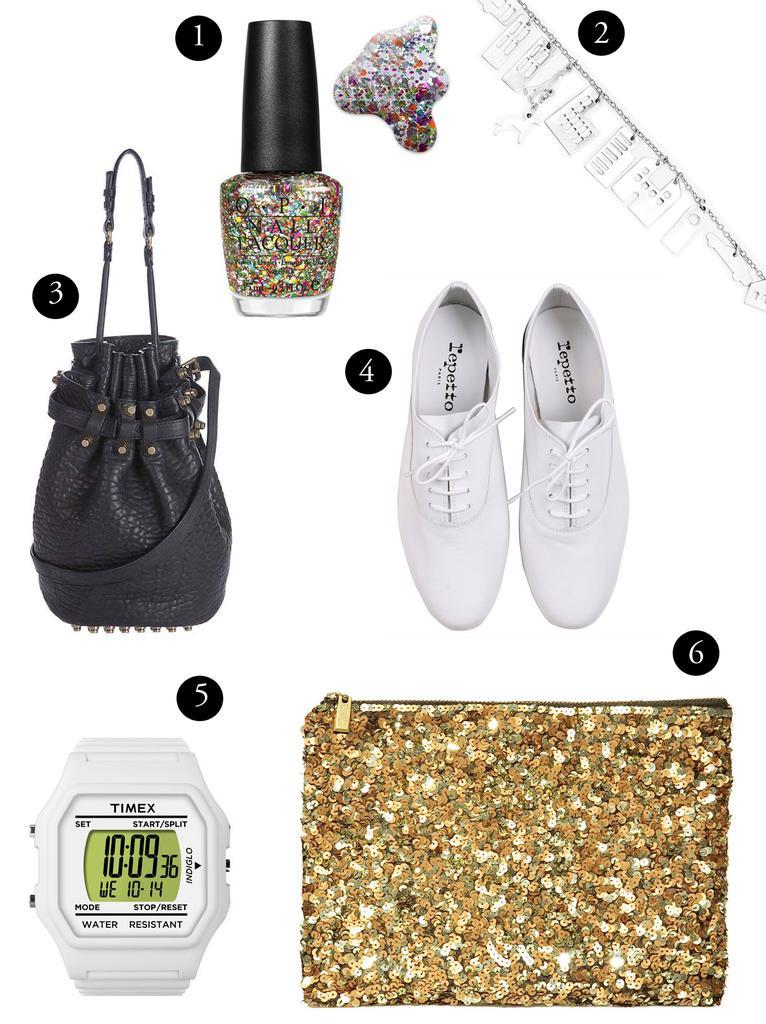How would you summarize this image in a sentence or two? In this Image I see a bag, nail polish, shoes, watch and few accessories. 